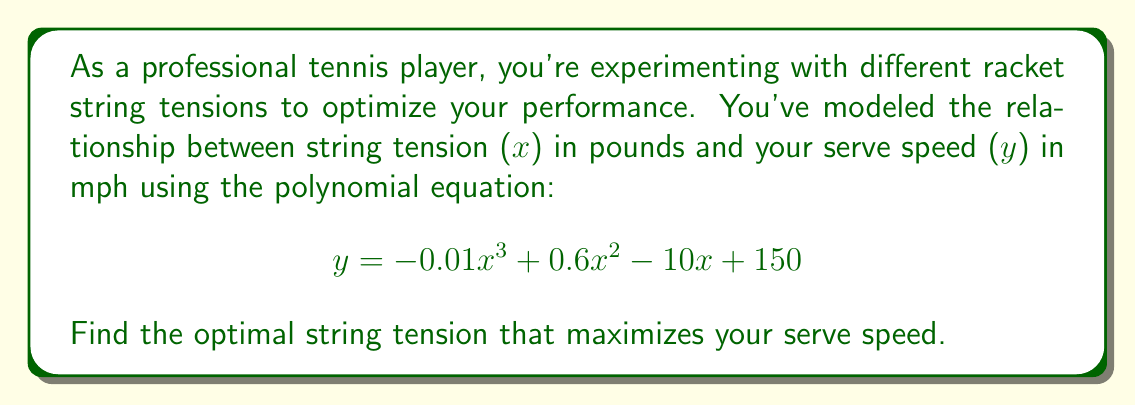Give your solution to this math problem. To find the optimal string tension, we need to find the maximum point of the given polynomial function. This occurs where the derivative of the function is zero.

Step 1: Find the derivative of the function.
$y = -0.01x^3 + 0.6x^2 - 10x + 150$
$\frac{dy}{dx} = -0.03x^2 + 1.2x - 10$

Step 2: Set the derivative equal to zero and solve for x.
$-0.03x^2 + 1.2x - 10 = 0$

Step 3: This is a quadratic equation. We can solve it using the quadratic formula:
$x = \frac{-b \pm \sqrt{b^2 - 4ac}}{2a}$

Where $a = -0.03$, $b = 1.2$, and $c = -10$

$x = \frac{-1.2 \pm \sqrt{1.2^2 - 4(-0.03)(-10)}}{2(-0.03)}$

$x = \frac{-1.2 \pm \sqrt{1.44 - 1.2}}{-0.06}$

$x = \frac{-1.2 \pm \sqrt{0.24}}{-0.06}$

$x = \frac{-1.2 \pm 0.4899}{-0.06}$

This gives us two solutions:
$x_1 = \frac{-1.2 + 0.4899}{-0.06} \approx 11.835$
$x_2 = \frac{-1.2 - 0.4899}{-0.06} \approx 28.165$

Step 4: To determine which solution gives the maximum, we can check the second derivative:
$\frac{d^2y}{dx^2} = -0.06x + 1.2$

At $x = 11.835$: $\frac{d^2y}{dx^2} = -0.06(11.835) + 1.2 = 0.4899 > 0$
At $x = 28.165$: $\frac{d^2y}{dx^2} = -0.06(28.165) + 1.2 = -0.4899 < 0$

Since the second derivative is negative at $x = 28.165$, this is the point of maximum serve speed.

Therefore, the optimal string tension is approximately 28.165 pounds.
Answer: 28.165 pounds 